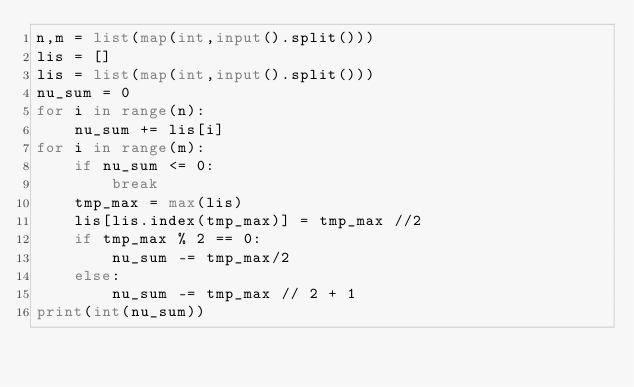<code> <loc_0><loc_0><loc_500><loc_500><_Python_>n,m = list(map(int,input().split()))
lis = []
lis = list(map(int,input().split()))
nu_sum = 0
for i in range(n):
    nu_sum += lis[i]
for i in range(m):
    if nu_sum <= 0:
        break
    tmp_max = max(lis)
    lis[lis.index(tmp_max)] = tmp_max //2
    if tmp_max % 2 == 0:
        nu_sum -= tmp_max/2
    else:
        nu_sum -= tmp_max // 2 + 1
print(int(nu_sum))
</code> 